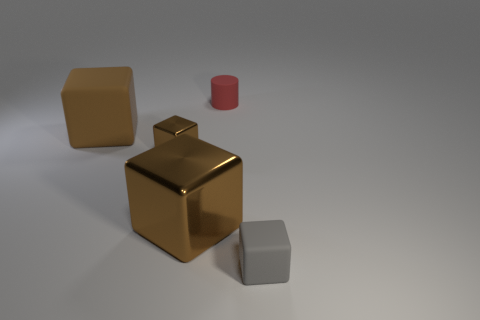Is the number of large brown cubes less than the number of red cylinders?
Make the answer very short. No. There is a rubber object that is both in front of the tiny red thing and behind the gray cube; what is its size?
Offer a very short reply. Large. What is the size of the rubber cube that is behind the rubber block that is on the right side of the big brown block to the left of the small brown shiny object?
Give a very brief answer. Large. The gray object has what size?
Offer a terse response. Small. Is there any other thing that is made of the same material as the tiny red object?
Provide a succinct answer. Yes. Are there any tiny gray cubes on the left side of the rubber block behind the rubber cube that is on the right side of the tiny brown object?
Your response must be concise. No. How many small objects are either cubes or brown matte things?
Give a very brief answer. 2. Is there anything else that is the same color as the rubber cylinder?
Offer a terse response. No. Do the rubber block that is on the left side of the cylinder and the small gray rubber object have the same size?
Your answer should be compact. No. There is a small matte object in front of the brown thing that is to the left of the small brown cube in front of the large matte object; what is its color?
Give a very brief answer. Gray. 